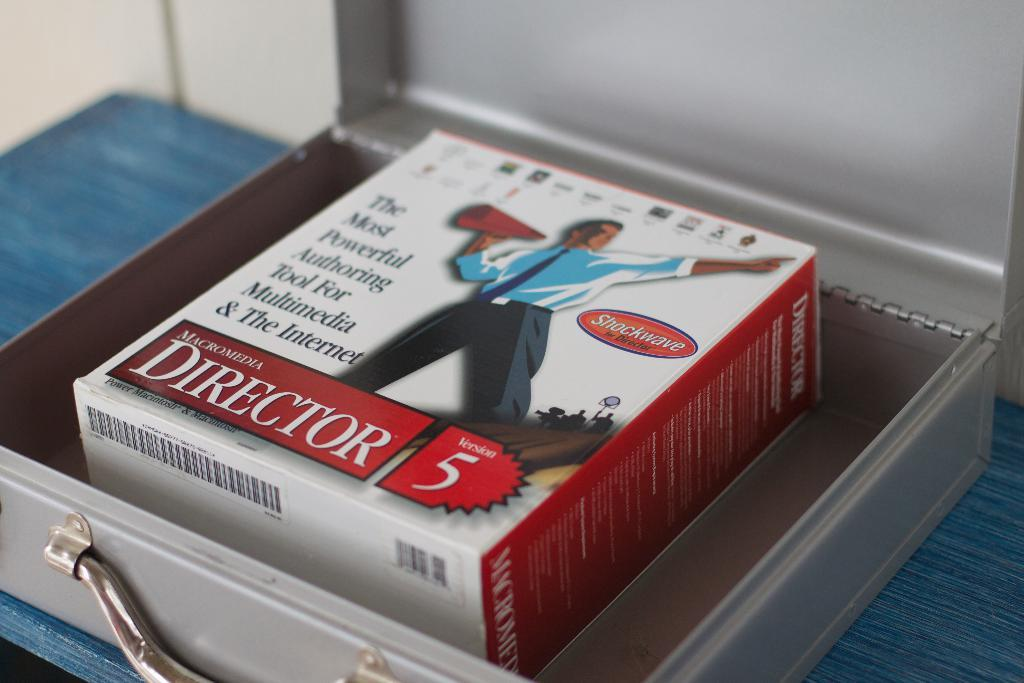What object is contained within the briefcase in the image? There is a box in the image, which is kept in a briefcase. What is the color of the surface on which the briefcase is placed? The briefcase is on a blue color surface. How many nails can be seen holding the earth together in the image? There is no depiction of the earth or nails in the image; it only features a box in a briefcase on a blue surface. 